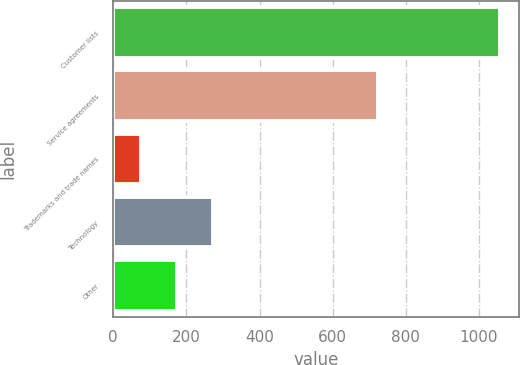<chart> <loc_0><loc_0><loc_500><loc_500><bar_chart><fcel>Customer lists<fcel>Service agreements<fcel>Trademarks and trade names<fcel>Technology<fcel>Other<nl><fcel>1057<fcel>723<fcel>76<fcel>272.2<fcel>174.1<nl></chart> 